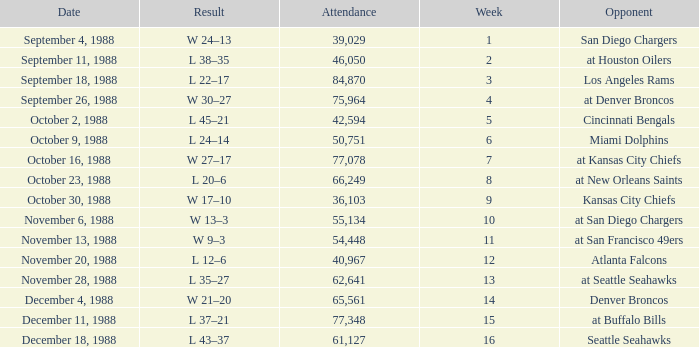What was the date during week 13? November 28, 1988. 